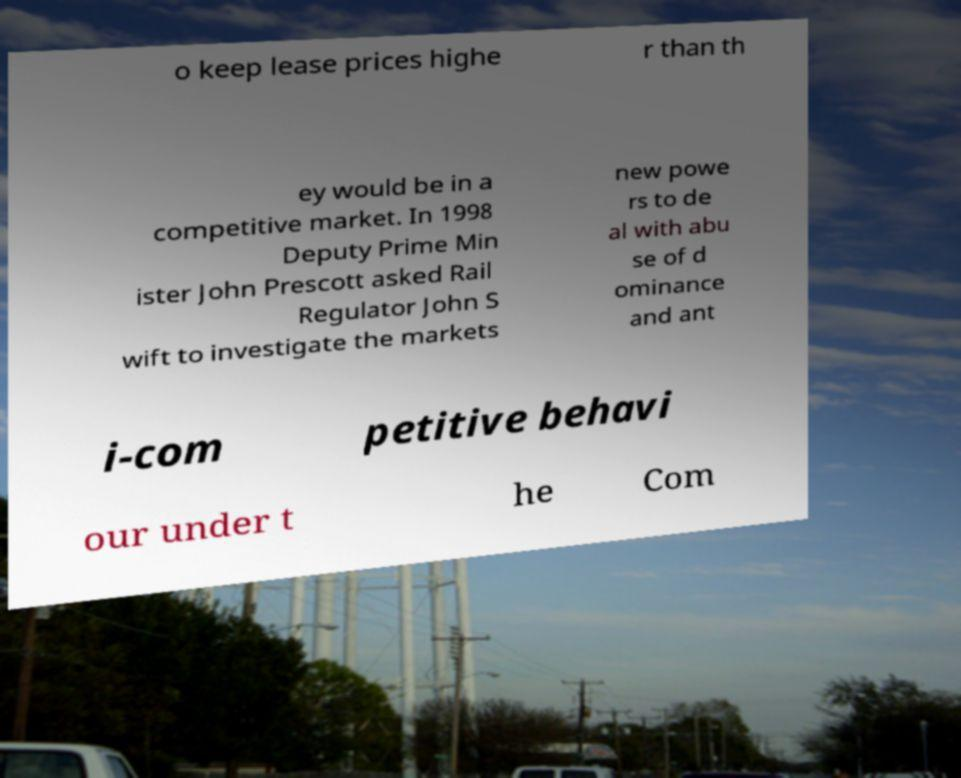I need the written content from this picture converted into text. Can you do that? o keep lease prices highe r than th ey would be in a competitive market. In 1998 Deputy Prime Min ister John Prescott asked Rail Regulator John S wift to investigate the markets new powe rs to de al with abu se of d ominance and ant i-com petitive behavi our under t he Com 